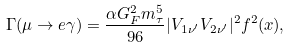<formula> <loc_0><loc_0><loc_500><loc_500>\Gamma ( \mu \to e \gamma ) = \frac { \alpha G _ { F } ^ { 2 } m _ { \tau } ^ { 5 } } { 9 6 } | V _ { 1 \nu ^ { \prime } } V _ { 2 \nu ^ { \prime } } | ^ { 2 } f ^ { 2 } ( x ) ,</formula> 